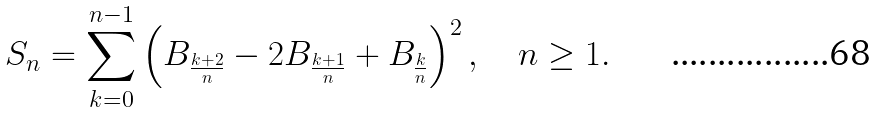Convert formula to latex. <formula><loc_0><loc_0><loc_500><loc_500>S _ { n } = \sum _ { k = 0 } ^ { n - 1 } \left ( B _ { \frac { k + 2 } n } - 2 B _ { \frac { k + 1 } n } + B _ { \frac { k } { n } } \right ) ^ { 2 } , \quad n \geq 1 .</formula> 